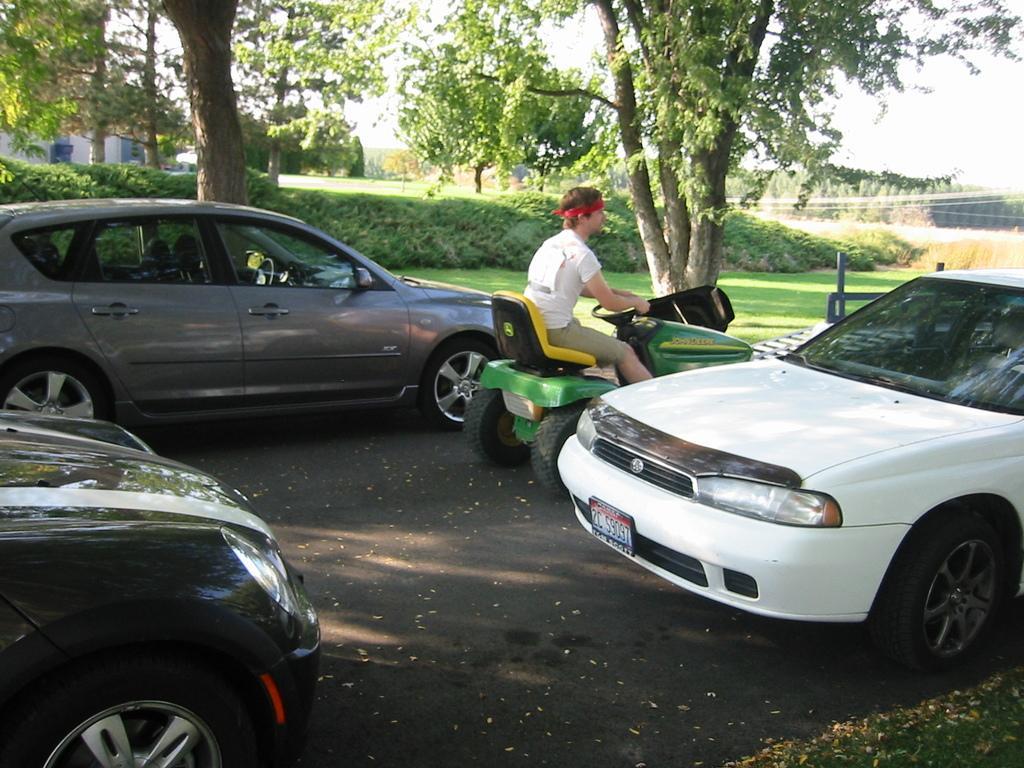Could you give a brief overview of what you see in this image? There are cars and a man in a vehicle in the foreground area of the image, there is greenery, it seems like house structures and the sky in the background. 